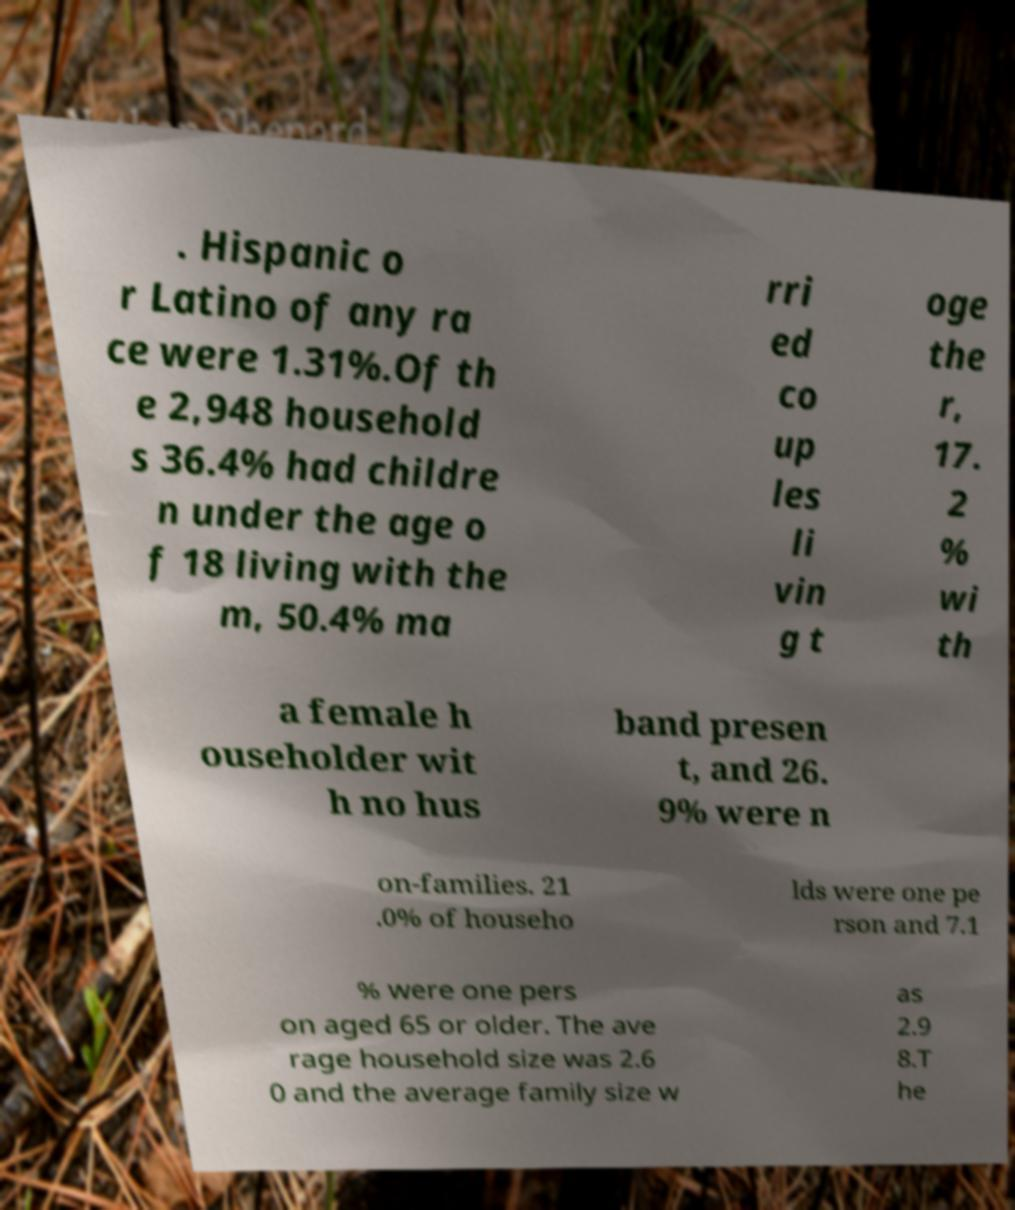Could you extract and type out the text from this image? . Hispanic o r Latino of any ra ce were 1.31%.Of th e 2,948 household s 36.4% had childre n under the age o f 18 living with the m, 50.4% ma rri ed co up les li vin g t oge the r, 17. 2 % wi th a female h ouseholder wit h no hus band presen t, and 26. 9% were n on-families. 21 .0% of househo lds were one pe rson and 7.1 % were one pers on aged 65 or older. The ave rage household size was 2.6 0 and the average family size w as 2.9 8.T he 